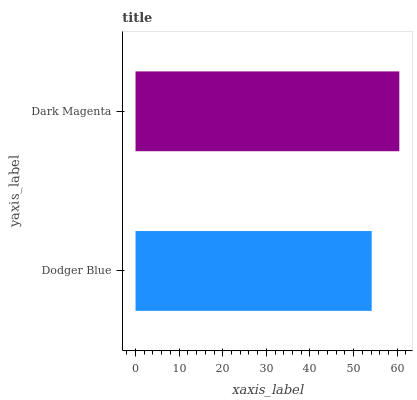Is Dodger Blue the minimum?
Answer yes or no. Yes. Is Dark Magenta the maximum?
Answer yes or no. Yes. Is Dark Magenta the minimum?
Answer yes or no. No. Is Dark Magenta greater than Dodger Blue?
Answer yes or no. Yes. Is Dodger Blue less than Dark Magenta?
Answer yes or no. Yes. Is Dodger Blue greater than Dark Magenta?
Answer yes or no. No. Is Dark Magenta less than Dodger Blue?
Answer yes or no. No. Is Dark Magenta the high median?
Answer yes or no. Yes. Is Dodger Blue the low median?
Answer yes or no. Yes. Is Dodger Blue the high median?
Answer yes or no. No. Is Dark Magenta the low median?
Answer yes or no. No. 